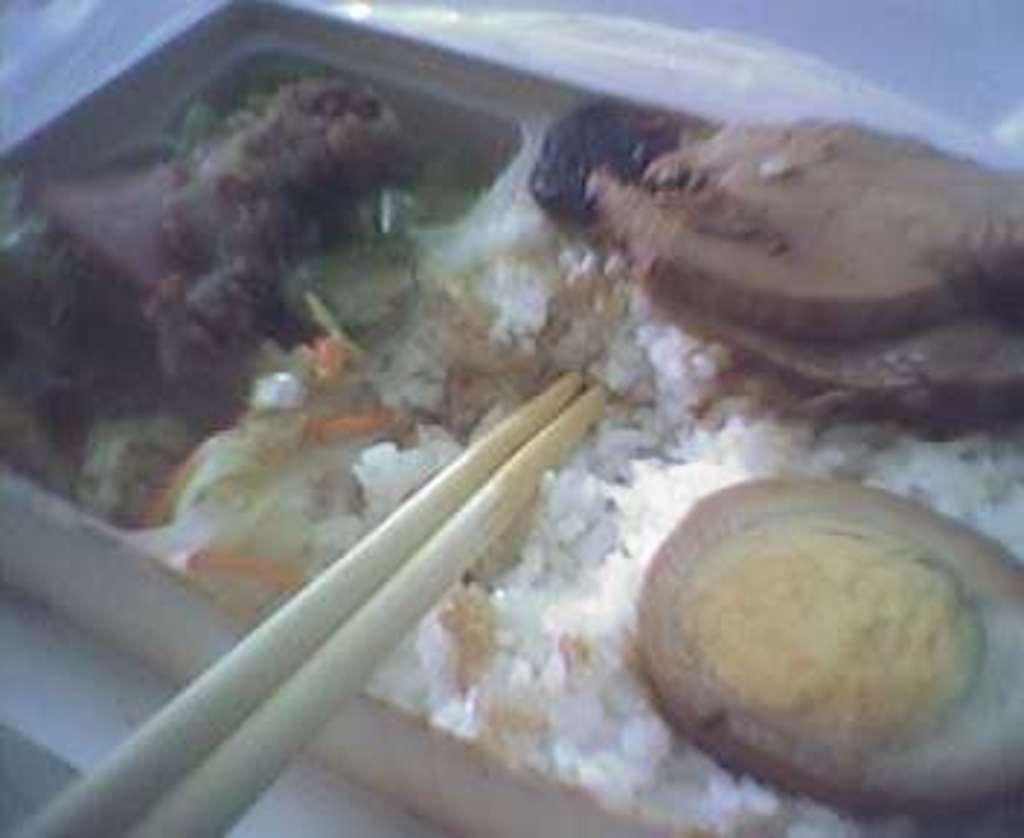What type of food can be seen in the image? There is food in the image, including meat and eggs. What is used to serve the food in the image? There is a plate in the image. What utensils are present in the image? There are chopsticks in the image. Can you see any pipes in the image? There are no pipes present in the image. Is there a window visible in the image? The provided facts do not mention a window, so we cannot determine if one is present in the image. 